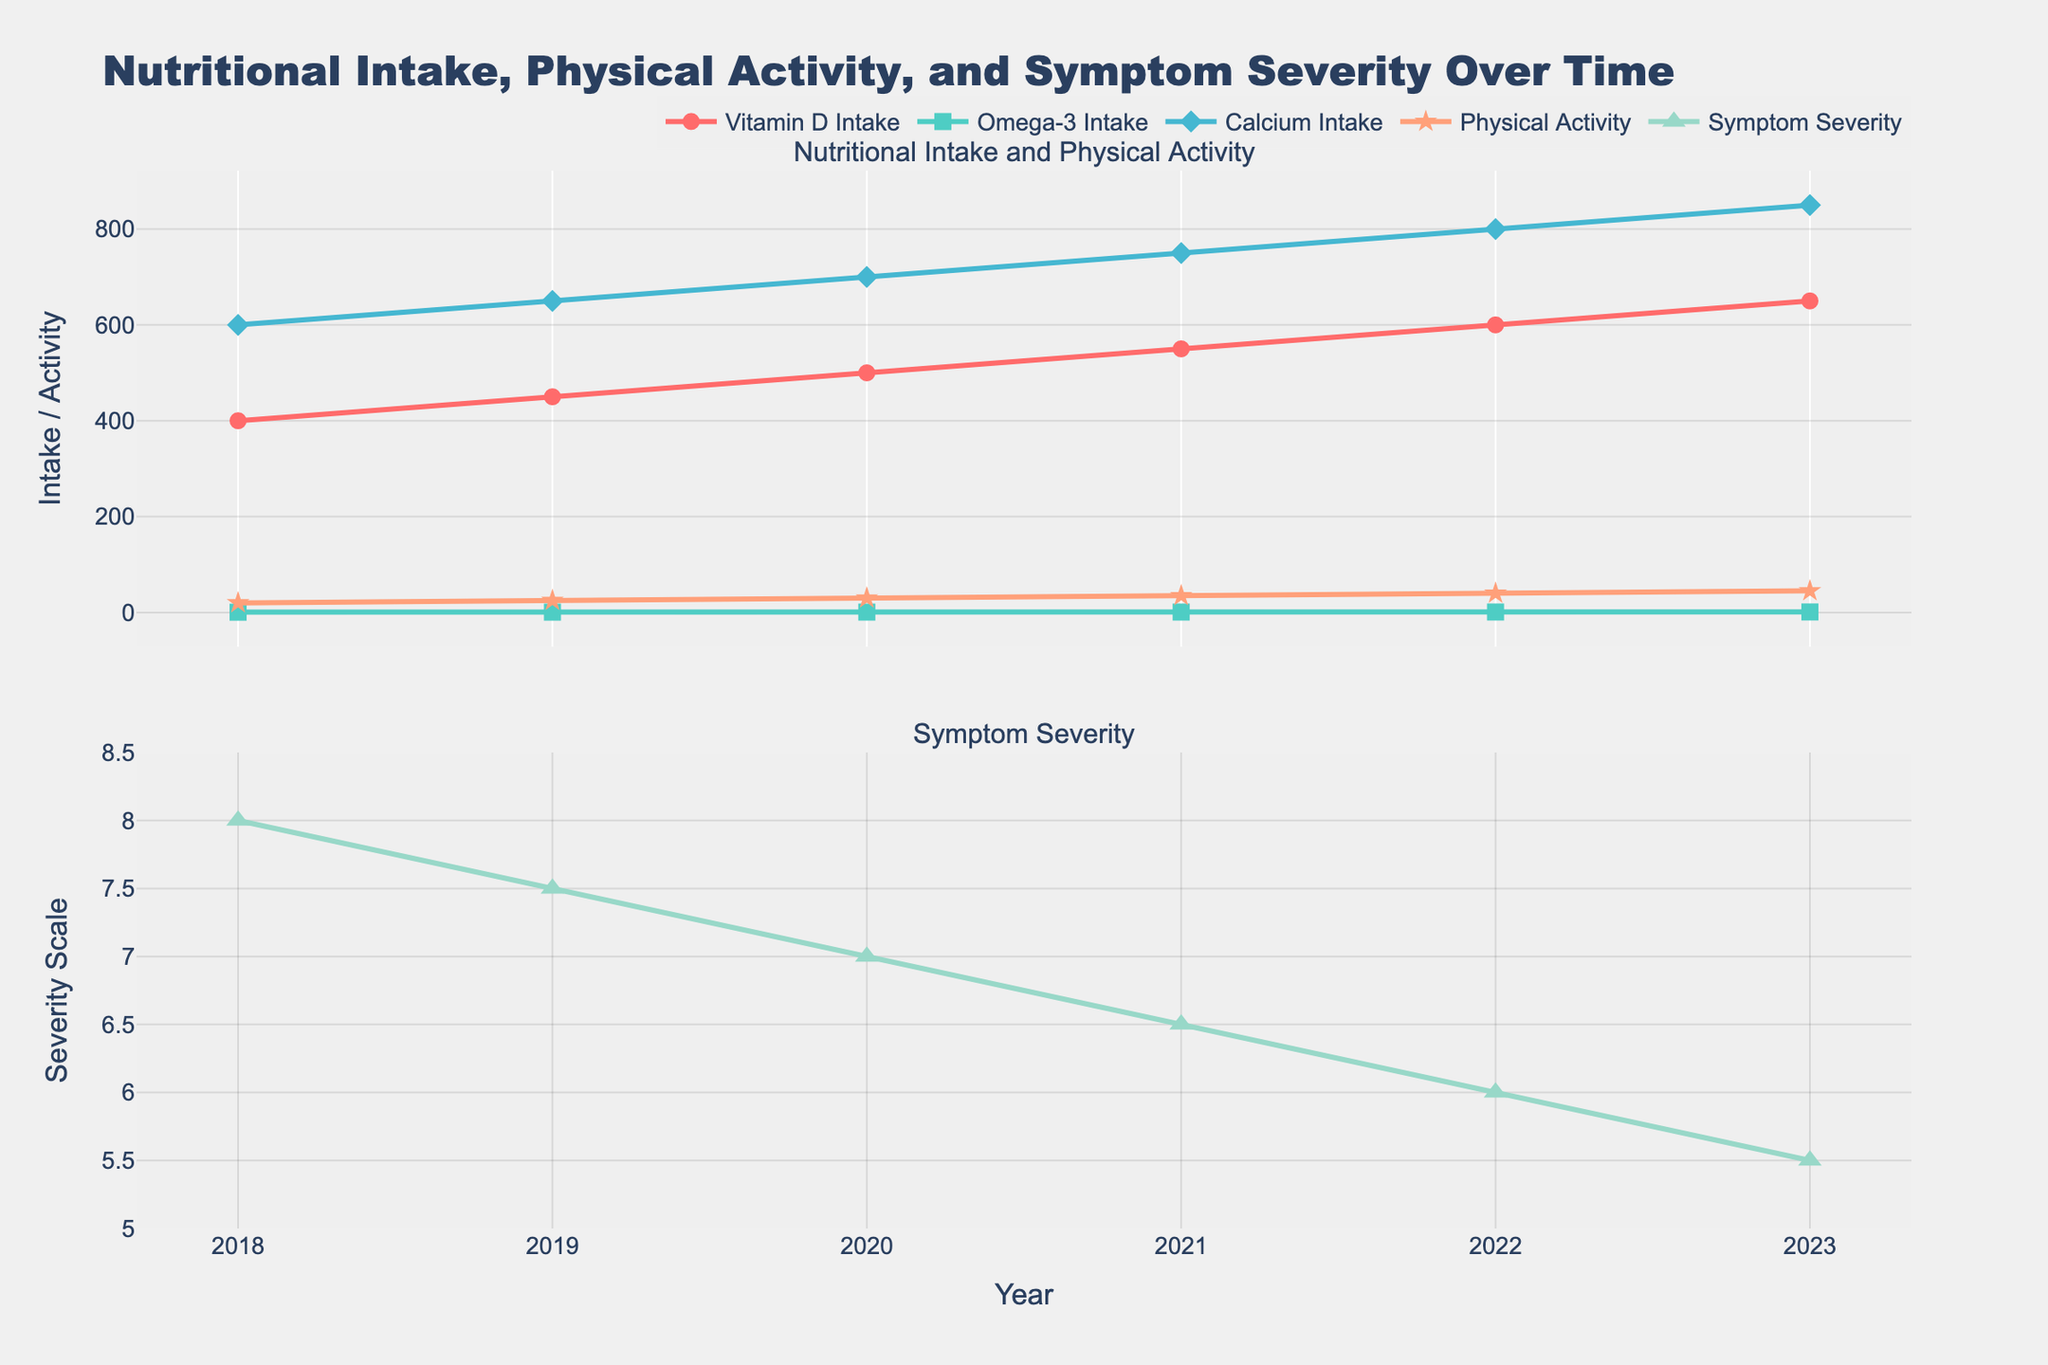What is the title of the figure? The title is located at the top of the figure, providing an overview of the content. It reads "Nutritional Intake, Physical Activity, and Symptom Severity Over Time".
Answer: Nutritional Intake, Physical Activity, and Symptom Severity Over Time How many years of data are represented in the plot? By looking at the x-axis, you can see data points start from 2018 and end in 2023. Counting these years gives us six data points.
Answer: 6 Which nutrient shows the steepest increase in intake over the years? All nutrients show a linear increase, but you need to observe the slopes. Calcium Intake rises from 600 mg/day to 850 mg/day in six years, a total increase of 250 mg/day, which is the steepest.
Answer: Calcium Intake In what year was the symptom severity at its highest level? The lowest plot in the second section shows symptom severity. It's apparent that 2018 has the highest severity level of 8.
Answer: 2018 How did physical activity change from 2018 to 2023? The physical activity trend line increases linearly. It starts at 20 minutes/day in 2018 and reaches 45 minutes/day in 2023. So, it increased by 25 minutes/day over six years.
Answer: Increased by 25 minutes/day What was the trend in Omega-3 intake and symptom severity between 2021 and 2023? From 2021 to 2023, Omega-3 intake continues to increase from 0.8g/day to 1.0g/day. Simultaneously, symptom severity decreases from 6.5 to 5.5.
Answer: Omega-3 intake increased and symptom severity decreased Which year had the least difference between calcium intake and physical activity? Check the difference in each year: 2018 (600 mg/day - 20 mins/day = 580), 2019 (625), 2020 (670), 2021 (715), 2022 (760), 2023 (805). The year 2018 has the smallest difference.
Answer: 2018 What is the main insight gained from the symptom severity plot? The symptom severity has a downward trend, moving from a score of 8 in 2018 to 5.5 in 2023, indicating an overall decrease in severity.
Answer: Decrease in severity How does the figure illustrate the correlation between nutritional intake and symptom severity? As Vitamin D, Omega-3, and Calcium Intake increase over the years, along with physical activity, there is a corresponding decrease in symptom severity. This visual representation suggests a negative correlation between nutrient intake/activity and symptom severity.
Answer: Negative correlation 